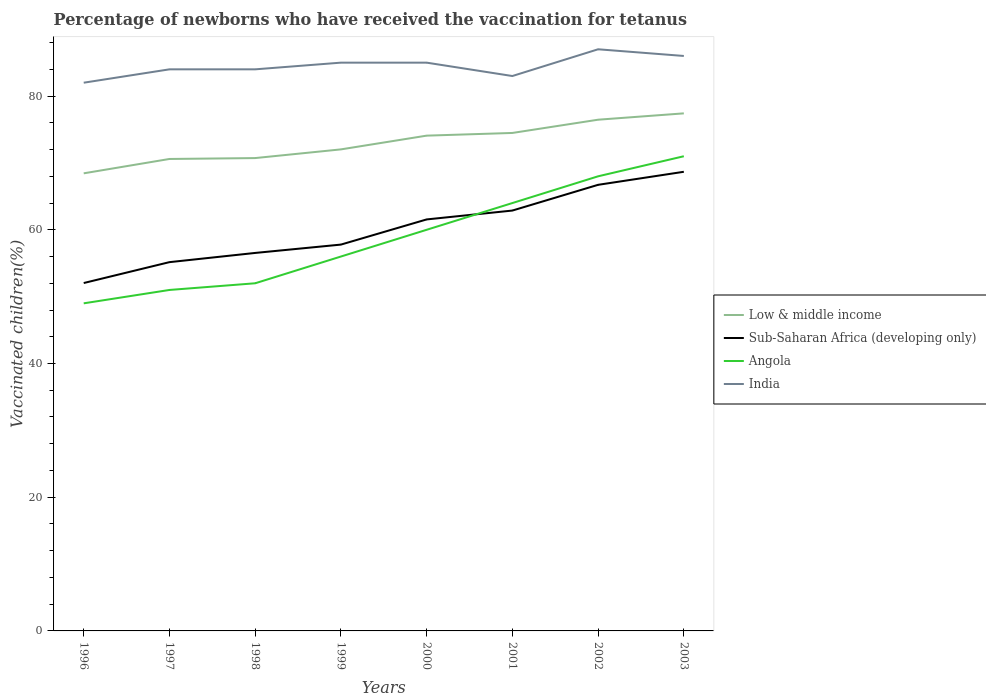How many different coloured lines are there?
Ensure brevity in your answer.  4. Does the line corresponding to Low & middle income intersect with the line corresponding to Sub-Saharan Africa (developing only)?
Offer a very short reply. No. Is the number of lines equal to the number of legend labels?
Keep it short and to the point. Yes. Across all years, what is the maximum percentage of vaccinated children in Low & middle income?
Offer a terse response. 68.45. What is the total percentage of vaccinated children in Sub-Saharan Africa (developing only) in the graph?
Provide a succinct answer. -7.13. What is the difference between the highest and the second highest percentage of vaccinated children in Sub-Saharan Africa (developing only)?
Provide a succinct answer. 16.64. What is the difference between the highest and the lowest percentage of vaccinated children in Sub-Saharan Africa (developing only)?
Your answer should be compact. 4. Is the percentage of vaccinated children in Angola strictly greater than the percentage of vaccinated children in Low & middle income over the years?
Make the answer very short. Yes. How many lines are there?
Offer a very short reply. 4. Does the graph contain any zero values?
Provide a short and direct response. No. How many legend labels are there?
Keep it short and to the point. 4. What is the title of the graph?
Your answer should be compact. Percentage of newborns who have received the vaccination for tetanus. What is the label or title of the X-axis?
Your answer should be very brief. Years. What is the label or title of the Y-axis?
Your answer should be very brief. Vaccinated children(%). What is the Vaccinated children(%) of Low & middle income in 1996?
Make the answer very short. 68.45. What is the Vaccinated children(%) of Sub-Saharan Africa (developing only) in 1996?
Give a very brief answer. 52.04. What is the Vaccinated children(%) of Angola in 1996?
Your answer should be very brief. 49. What is the Vaccinated children(%) in Low & middle income in 1997?
Your response must be concise. 70.59. What is the Vaccinated children(%) of Sub-Saharan Africa (developing only) in 1997?
Provide a short and direct response. 55.16. What is the Vaccinated children(%) of Angola in 1997?
Offer a terse response. 51. What is the Vaccinated children(%) in India in 1997?
Your answer should be very brief. 84. What is the Vaccinated children(%) in Low & middle income in 1998?
Make the answer very short. 70.73. What is the Vaccinated children(%) of Sub-Saharan Africa (developing only) in 1998?
Your answer should be compact. 56.54. What is the Vaccinated children(%) of Low & middle income in 1999?
Provide a short and direct response. 72.03. What is the Vaccinated children(%) of Sub-Saharan Africa (developing only) in 1999?
Your answer should be compact. 57.79. What is the Vaccinated children(%) of Angola in 1999?
Keep it short and to the point. 56. What is the Vaccinated children(%) in Low & middle income in 2000?
Keep it short and to the point. 74.08. What is the Vaccinated children(%) in Sub-Saharan Africa (developing only) in 2000?
Offer a terse response. 61.55. What is the Vaccinated children(%) of India in 2000?
Keep it short and to the point. 85. What is the Vaccinated children(%) of Low & middle income in 2001?
Your response must be concise. 74.48. What is the Vaccinated children(%) in Sub-Saharan Africa (developing only) in 2001?
Your response must be concise. 62.88. What is the Vaccinated children(%) in India in 2001?
Give a very brief answer. 83. What is the Vaccinated children(%) of Low & middle income in 2002?
Your response must be concise. 76.47. What is the Vaccinated children(%) of Sub-Saharan Africa (developing only) in 2002?
Provide a succinct answer. 66.73. What is the Vaccinated children(%) in Angola in 2002?
Keep it short and to the point. 68. What is the Vaccinated children(%) of India in 2002?
Offer a very short reply. 87. What is the Vaccinated children(%) in Low & middle income in 2003?
Your response must be concise. 77.41. What is the Vaccinated children(%) in Sub-Saharan Africa (developing only) in 2003?
Your response must be concise. 68.68. What is the Vaccinated children(%) of India in 2003?
Offer a terse response. 86. Across all years, what is the maximum Vaccinated children(%) in Low & middle income?
Keep it short and to the point. 77.41. Across all years, what is the maximum Vaccinated children(%) of Sub-Saharan Africa (developing only)?
Your response must be concise. 68.68. Across all years, what is the maximum Vaccinated children(%) in Angola?
Make the answer very short. 71. Across all years, what is the minimum Vaccinated children(%) in Low & middle income?
Make the answer very short. 68.45. Across all years, what is the minimum Vaccinated children(%) of Sub-Saharan Africa (developing only)?
Give a very brief answer. 52.04. Across all years, what is the minimum Vaccinated children(%) in India?
Provide a succinct answer. 82. What is the total Vaccinated children(%) of Low & middle income in the graph?
Your answer should be compact. 584.24. What is the total Vaccinated children(%) of Sub-Saharan Africa (developing only) in the graph?
Make the answer very short. 481.35. What is the total Vaccinated children(%) in Angola in the graph?
Keep it short and to the point. 471. What is the total Vaccinated children(%) in India in the graph?
Offer a very short reply. 676. What is the difference between the Vaccinated children(%) of Low & middle income in 1996 and that in 1997?
Ensure brevity in your answer.  -2.15. What is the difference between the Vaccinated children(%) in Sub-Saharan Africa (developing only) in 1996 and that in 1997?
Your answer should be compact. -3.13. What is the difference between the Vaccinated children(%) of Angola in 1996 and that in 1997?
Your response must be concise. -2. What is the difference between the Vaccinated children(%) in India in 1996 and that in 1997?
Provide a short and direct response. -2. What is the difference between the Vaccinated children(%) of Low & middle income in 1996 and that in 1998?
Ensure brevity in your answer.  -2.28. What is the difference between the Vaccinated children(%) of Sub-Saharan Africa (developing only) in 1996 and that in 1998?
Keep it short and to the point. -4.5. What is the difference between the Vaccinated children(%) of Angola in 1996 and that in 1998?
Keep it short and to the point. -3. What is the difference between the Vaccinated children(%) in India in 1996 and that in 1998?
Provide a short and direct response. -2. What is the difference between the Vaccinated children(%) of Low & middle income in 1996 and that in 1999?
Offer a very short reply. -3.58. What is the difference between the Vaccinated children(%) of Sub-Saharan Africa (developing only) in 1996 and that in 1999?
Your response must be concise. -5.75. What is the difference between the Vaccinated children(%) in Angola in 1996 and that in 1999?
Offer a very short reply. -7. What is the difference between the Vaccinated children(%) of India in 1996 and that in 1999?
Your answer should be compact. -3. What is the difference between the Vaccinated children(%) in Low & middle income in 1996 and that in 2000?
Keep it short and to the point. -5.64. What is the difference between the Vaccinated children(%) of Sub-Saharan Africa (developing only) in 1996 and that in 2000?
Your response must be concise. -9.51. What is the difference between the Vaccinated children(%) in Angola in 1996 and that in 2000?
Keep it short and to the point. -11. What is the difference between the Vaccinated children(%) in Low & middle income in 1996 and that in 2001?
Your response must be concise. -6.04. What is the difference between the Vaccinated children(%) of Sub-Saharan Africa (developing only) in 1996 and that in 2001?
Offer a very short reply. -10.84. What is the difference between the Vaccinated children(%) in Angola in 1996 and that in 2001?
Your response must be concise. -15. What is the difference between the Vaccinated children(%) in Low & middle income in 1996 and that in 2002?
Your answer should be very brief. -8.02. What is the difference between the Vaccinated children(%) of Sub-Saharan Africa (developing only) in 1996 and that in 2002?
Provide a short and direct response. -14.69. What is the difference between the Vaccinated children(%) of Low & middle income in 1996 and that in 2003?
Provide a succinct answer. -8.97. What is the difference between the Vaccinated children(%) in Sub-Saharan Africa (developing only) in 1996 and that in 2003?
Provide a succinct answer. -16.64. What is the difference between the Vaccinated children(%) of Angola in 1996 and that in 2003?
Offer a very short reply. -22. What is the difference between the Vaccinated children(%) in India in 1996 and that in 2003?
Your answer should be compact. -4. What is the difference between the Vaccinated children(%) in Low & middle income in 1997 and that in 1998?
Ensure brevity in your answer.  -0.13. What is the difference between the Vaccinated children(%) of Sub-Saharan Africa (developing only) in 1997 and that in 1998?
Provide a succinct answer. -1.38. What is the difference between the Vaccinated children(%) of Angola in 1997 and that in 1998?
Ensure brevity in your answer.  -1. What is the difference between the Vaccinated children(%) of India in 1997 and that in 1998?
Your answer should be very brief. 0. What is the difference between the Vaccinated children(%) in Low & middle income in 1997 and that in 1999?
Your answer should be compact. -1.43. What is the difference between the Vaccinated children(%) in Sub-Saharan Africa (developing only) in 1997 and that in 1999?
Your answer should be compact. -2.62. What is the difference between the Vaccinated children(%) of Low & middle income in 1997 and that in 2000?
Provide a succinct answer. -3.49. What is the difference between the Vaccinated children(%) of Sub-Saharan Africa (developing only) in 1997 and that in 2000?
Offer a terse response. -6.39. What is the difference between the Vaccinated children(%) of Low & middle income in 1997 and that in 2001?
Your answer should be compact. -3.89. What is the difference between the Vaccinated children(%) of Sub-Saharan Africa (developing only) in 1997 and that in 2001?
Keep it short and to the point. -7.72. What is the difference between the Vaccinated children(%) of India in 1997 and that in 2001?
Your response must be concise. 1. What is the difference between the Vaccinated children(%) in Low & middle income in 1997 and that in 2002?
Ensure brevity in your answer.  -5.87. What is the difference between the Vaccinated children(%) of Sub-Saharan Africa (developing only) in 1997 and that in 2002?
Your answer should be very brief. -11.57. What is the difference between the Vaccinated children(%) in Low & middle income in 1997 and that in 2003?
Ensure brevity in your answer.  -6.82. What is the difference between the Vaccinated children(%) in Sub-Saharan Africa (developing only) in 1997 and that in 2003?
Your answer should be very brief. -13.52. What is the difference between the Vaccinated children(%) in Angola in 1997 and that in 2003?
Offer a very short reply. -20. What is the difference between the Vaccinated children(%) of Low & middle income in 1998 and that in 1999?
Your answer should be very brief. -1.3. What is the difference between the Vaccinated children(%) in Sub-Saharan Africa (developing only) in 1998 and that in 1999?
Provide a short and direct response. -1.25. What is the difference between the Vaccinated children(%) in Angola in 1998 and that in 1999?
Keep it short and to the point. -4. What is the difference between the Vaccinated children(%) in Low & middle income in 1998 and that in 2000?
Give a very brief answer. -3.36. What is the difference between the Vaccinated children(%) of Sub-Saharan Africa (developing only) in 1998 and that in 2000?
Make the answer very short. -5.01. What is the difference between the Vaccinated children(%) in Low & middle income in 1998 and that in 2001?
Provide a succinct answer. -3.76. What is the difference between the Vaccinated children(%) in Sub-Saharan Africa (developing only) in 1998 and that in 2001?
Provide a short and direct response. -6.34. What is the difference between the Vaccinated children(%) in Low & middle income in 1998 and that in 2002?
Provide a short and direct response. -5.74. What is the difference between the Vaccinated children(%) of Sub-Saharan Africa (developing only) in 1998 and that in 2002?
Offer a very short reply. -10.19. What is the difference between the Vaccinated children(%) of India in 1998 and that in 2002?
Your answer should be very brief. -3. What is the difference between the Vaccinated children(%) in Low & middle income in 1998 and that in 2003?
Offer a very short reply. -6.69. What is the difference between the Vaccinated children(%) in Sub-Saharan Africa (developing only) in 1998 and that in 2003?
Offer a very short reply. -12.14. What is the difference between the Vaccinated children(%) of Angola in 1998 and that in 2003?
Make the answer very short. -19. What is the difference between the Vaccinated children(%) of India in 1998 and that in 2003?
Your answer should be compact. -2. What is the difference between the Vaccinated children(%) in Low & middle income in 1999 and that in 2000?
Keep it short and to the point. -2.06. What is the difference between the Vaccinated children(%) of Sub-Saharan Africa (developing only) in 1999 and that in 2000?
Your response must be concise. -3.76. What is the difference between the Vaccinated children(%) of Low & middle income in 1999 and that in 2001?
Ensure brevity in your answer.  -2.46. What is the difference between the Vaccinated children(%) of Sub-Saharan Africa (developing only) in 1999 and that in 2001?
Your answer should be very brief. -5.09. What is the difference between the Vaccinated children(%) in Angola in 1999 and that in 2001?
Keep it short and to the point. -8. What is the difference between the Vaccinated children(%) of Low & middle income in 1999 and that in 2002?
Your response must be concise. -4.44. What is the difference between the Vaccinated children(%) in Sub-Saharan Africa (developing only) in 1999 and that in 2002?
Provide a succinct answer. -8.94. What is the difference between the Vaccinated children(%) of Low & middle income in 1999 and that in 2003?
Your answer should be very brief. -5.39. What is the difference between the Vaccinated children(%) of Sub-Saharan Africa (developing only) in 1999 and that in 2003?
Keep it short and to the point. -10.89. What is the difference between the Vaccinated children(%) of India in 1999 and that in 2003?
Your answer should be compact. -1. What is the difference between the Vaccinated children(%) of Low & middle income in 2000 and that in 2001?
Your response must be concise. -0.4. What is the difference between the Vaccinated children(%) in Sub-Saharan Africa (developing only) in 2000 and that in 2001?
Make the answer very short. -1.33. What is the difference between the Vaccinated children(%) in Low & middle income in 2000 and that in 2002?
Provide a succinct answer. -2.38. What is the difference between the Vaccinated children(%) in Sub-Saharan Africa (developing only) in 2000 and that in 2002?
Provide a short and direct response. -5.18. What is the difference between the Vaccinated children(%) of Angola in 2000 and that in 2002?
Your response must be concise. -8. What is the difference between the Vaccinated children(%) in Low & middle income in 2000 and that in 2003?
Keep it short and to the point. -3.33. What is the difference between the Vaccinated children(%) in Sub-Saharan Africa (developing only) in 2000 and that in 2003?
Make the answer very short. -7.13. What is the difference between the Vaccinated children(%) of Low & middle income in 2001 and that in 2002?
Make the answer very short. -1.98. What is the difference between the Vaccinated children(%) of Sub-Saharan Africa (developing only) in 2001 and that in 2002?
Your answer should be compact. -3.85. What is the difference between the Vaccinated children(%) in India in 2001 and that in 2002?
Provide a short and direct response. -4. What is the difference between the Vaccinated children(%) in Low & middle income in 2001 and that in 2003?
Offer a terse response. -2.93. What is the difference between the Vaccinated children(%) of Sub-Saharan Africa (developing only) in 2001 and that in 2003?
Ensure brevity in your answer.  -5.8. What is the difference between the Vaccinated children(%) of Low & middle income in 2002 and that in 2003?
Provide a short and direct response. -0.95. What is the difference between the Vaccinated children(%) of Sub-Saharan Africa (developing only) in 2002 and that in 2003?
Your response must be concise. -1.95. What is the difference between the Vaccinated children(%) in Angola in 2002 and that in 2003?
Provide a short and direct response. -3. What is the difference between the Vaccinated children(%) in Low & middle income in 1996 and the Vaccinated children(%) in Sub-Saharan Africa (developing only) in 1997?
Keep it short and to the point. 13.28. What is the difference between the Vaccinated children(%) of Low & middle income in 1996 and the Vaccinated children(%) of Angola in 1997?
Your answer should be compact. 17.45. What is the difference between the Vaccinated children(%) in Low & middle income in 1996 and the Vaccinated children(%) in India in 1997?
Ensure brevity in your answer.  -15.55. What is the difference between the Vaccinated children(%) of Sub-Saharan Africa (developing only) in 1996 and the Vaccinated children(%) of Angola in 1997?
Give a very brief answer. 1.04. What is the difference between the Vaccinated children(%) of Sub-Saharan Africa (developing only) in 1996 and the Vaccinated children(%) of India in 1997?
Your response must be concise. -31.96. What is the difference between the Vaccinated children(%) in Angola in 1996 and the Vaccinated children(%) in India in 1997?
Make the answer very short. -35. What is the difference between the Vaccinated children(%) of Low & middle income in 1996 and the Vaccinated children(%) of Sub-Saharan Africa (developing only) in 1998?
Your answer should be very brief. 11.91. What is the difference between the Vaccinated children(%) of Low & middle income in 1996 and the Vaccinated children(%) of Angola in 1998?
Keep it short and to the point. 16.45. What is the difference between the Vaccinated children(%) in Low & middle income in 1996 and the Vaccinated children(%) in India in 1998?
Provide a succinct answer. -15.55. What is the difference between the Vaccinated children(%) of Sub-Saharan Africa (developing only) in 1996 and the Vaccinated children(%) of Angola in 1998?
Your answer should be very brief. 0.04. What is the difference between the Vaccinated children(%) in Sub-Saharan Africa (developing only) in 1996 and the Vaccinated children(%) in India in 1998?
Ensure brevity in your answer.  -31.96. What is the difference between the Vaccinated children(%) of Angola in 1996 and the Vaccinated children(%) of India in 1998?
Your answer should be compact. -35. What is the difference between the Vaccinated children(%) in Low & middle income in 1996 and the Vaccinated children(%) in Sub-Saharan Africa (developing only) in 1999?
Provide a short and direct response. 10.66. What is the difference between the Vaccinated children(%) in Low & middle income in 1996 and the Vaccinated children(%) in Angola in 1999?
Your answer should be compact. 12.45. What is the difference between the Vaccinated children(%) in Low & middle income in 1996 and the Vaccinated children(%) in India in 1999?
Give a very brief answer. -16.55. What is the difference between the Vaccinated children(%) in Sub-Saharan Africa (developing only) in 1996 and the Vaccinated children(%) in Angola in 1999?
Your answer should be very brief. -3.96. What is the difference between the Vaccinated children(%) in Sub-Saharan Africa (developing only) in 1996 and the Vaccinated children(%) in India in 1999?
Your answer should be very brief. -32.96. What is the difference between the Vaccinated children(%) of Angola in 1996 and the Vaccinated children(%) of India in 1999?
Offer a very short reply. -36. What is the difference between the Vaccinated children(%) in Low & middle income in 1996 and the Vaccinated children(%) in Sub-Saharan Africa (developing only) in 2000?
Your response must be concise. 6.9. What is the difference between the Vaccinated children(%) of Low & middle income in 1996 and the Vaccinated children(%) of Angola in 2000?
Keep it short and to the point. 8.45. What is the difference between the Vaccinated children(%) of Low & middle income in 1996 and the Vaccinated children(%) of India in 2000?
Make the answer very short. -16.55. What is the difference between the Vaccinated children(%) of Sub-Saharan Africa (developing only) in 1996 and the Vaccinated children(%) of Angola in 2000?
Your answer should be very brief. -7.96. What is the difference between the Vaccinated children(%) in Sub-Saharan Africa (developing only) in 1996 and the Vaccinated children(%) in India in 2000?
Your answer should be compact. -32.96. What is the difference between the Vaccinated children(%) of Angola in 1996 and the Vaccinated children(%) of India in 2000?
Offer a very short reply. -36. What is the difference between the Vaccinated children(%) in Low & middle income in 1996 and the Vaccinated children(%) in Sub-Saharan Africa (developing only) in 2001?
Provide a succinct answer. 5.57. What is the difference between the Vaccinated children(%) of Low & middle income in 1996 and the Vaccinated children(%) of Angola in 2001?
Your response must be concise. 4.45. What is the difference between the Vaccinated children(%) of Low & middle income in 1996 and the Vaccinated children(%) of India in 2001?
Give a very brief answer. -14.55. What is the difference between the Vaccinated children(%) of Sub-Saharan Africa (developing only) in 1996 and the Vaccinated children(%) of Angola in 2001?
Your answer should be compact. -11.96. What is the difference between the Vaccinated children(%) of Sub-Saharan Africa (developing only) in 1996 and the Vaccinated children(%) of India in 2001?
Provide a short and direct response. -30.96. What is the difference between the Vaccinated children(%) of Angola in 1996 and the Vaccinated children(%) of India in 2001?
Keep it short and to the point. -34. What is the difference between the Vaccinated children(%) in Low & middle income in 1996 and the Vaccinated children(%) in Sub-Saharan Africa (developing only) in 2002?
Give a very brief answer. 1.72. What is the difference between the Vaccinated children(%) in Low & middle income in 1996 and the Vaccinated children(%) in Angola in 2002?
Offer a very short reply. 0.45. What is the difference between the Vaccinated children(%) in Low & middle income in 1996 and the Vaccinated children(%) in India in 2002?
Your response must be concise. -18.55. What is the difference between the Vaccinated children(%) in Sub-Saharan Africa (developing only) in 1996 and the Vaccinated children(%) in Angola in 2002?
Give a very brief answer. -15.96. What is the difference between the Vaccinated children(%) in Sub-Saharan Africa (developing only) in 1996 and the Vaccinated children(%) in India in 2002?
Keep it short and to the point. -34.96. What is the difference between the Vaccinated children(%) of Angola in 1996 and the Vaccinated children(%) of India in 2002?
Your answer should be very brief. -38. What is the difference between the Vaccinated children(%) in Low & middle income in 1996 and the Vaccinated children(%) in Sub-Saharan Africa (developing only) in 2003?
Your response must be concise. -0.23. What is the difference between the Vaccinated children(%) of Low & middle income in 1996 and the Vaccinated children(%) of Angola in 2003?
Give a very brief answer. -2.55. What is the difference between the Vaccinated children(%) of Low & middle income in 1996 and the Vaccinated children(%) of India in 2003?
Provide a short and direct response. -17.55. What is the difference between the Vaccinated children(%) of Sub-Saharan Africa (developing only) in 1996 and the Vaccinated children(%) of Angola in 2003?
Make the answer very short. -18.96. What is the difference between the Vaccinated children(%) in Sub-Saharan Africa (developing only) in 1996 and the Vaccinated children(%) in India in 2003?
Offer a terse response. -33.96. What is the difference between the Vaccinated children(%) in Angola in 1996 and the Vaccinated children(%) in India in 2003?
Make the answer very short. -37. What is the difference between the Vaccinated children(%) in Low & middle income in 1997 and the Vaccinated children(%) in Sub-Saharan Africa (developing only) in 1998?
Make the answer very short. 14.06. What is the difference between the Vaccinated children(%) of Low & middle income in 1997 and the Vaccinated children(%) of Angola in 1998?
Provide a short and direct response. 18.59. What is the difference between the Vaccinated children(%) of Low & middle income in 1997 and the Vaccinated children(%) of India in 1998?
Offer a very short reply. -13.41. What is the difference between the Vaccinated children(%) in Sub-Saharan Africa (developing only) in 1997 and the Vaccinated children(%) in Angola in 1998?
Your answer should be compact. 3.16. What is the difference between the Vaccinated children(%) of Sub-Saharan Africa (developing only) in 1997 and the Vaccinated children(%) of India in 1998?
Your answer should be very brief. -28.84. What is the difference between the Vaccinated children(%) in Angola in 1997 and the Vaccinated children(%) in India in 1998?
Give a very brief answer. -33. What is the difference between the Vaccinated children(%) of Low & middle income in 1997 and the Vaccinated children(%) of Sub-Saharan Africa (developing only) in 1999?
Offer a very short reply. 12.81. What is the difference between the Vaccinated children(%) in Low & middle income in 1997 and the Vaccinated children(%) in Angola in 1999?
Offer a terse response. 14.59. What is the difference between the Vaccinated children(%) of Low & middle income in 1997 and the Vaccinated children(%) of India in 1999?
Offer a very short reply. -14.41. What is the difference between the Vaccinated children(%) in Sub-Saharan Africa (developing only) in 1997 and the Vaccinated children(%) in Angola in 1999?
Make the answer very short. -0.84. What is the difference between the Vaccinated children(%) in Sub-Saharan Africa (developing only) in 1997 and the Vaccinated children(%) in India in 1999?
Give a very brief answer. -29.84. What is the difference between the Vaccinated children(%) of Angola in 1997 and the Vaccinated children(%) of India in 1999?
Offer a terse response. -34. What is the difference between the Vaccinated children(%) of Low & middle income in 1997 and the Vaccinated children(%) of Sub-Saharan Africa (developing only) in 2000?
Provide a short and direct response. 9.04. What is the difference between the Vaccinated children(%) of Low & middle income in 1997 and the Vaccinated children(%) of Angola in 2000?
Your answer should be very brief. 10.59. What is the difference between the Vaccinated children(%) of Low & middle income in 1997 and the Vaccinated children(%) of India in 2000?
Offer a terse response. -14.41. What is the difference between the Vaccinated children(%) of Sub-Saharan Africa (developing only) in 1997 and the Vaccinated children(%) of Angola in 2000?
Your answer should be very brief. -4.84. What is the difference between the Vaccinated children(%) of Sub-Saharan Africa (developing only) in 1997 and the Vaccinated children(%) of India in 2000?
Offer a very short reply. -29.84. What is the difference between the Vaccinated children(%) in Angola in 1997 and the Vaccinated children(%) in India in 2000?
Your answer should be very brief. -34. What is the difference between the Vaccinated children(%) in Low & middle income in 1997 and the Vaccinated children(%) in Sub-Saharan Africa (developing only) in 2001?
Provide a succinct answer. 7.72. What is the difference between the Vaccinated children(%) of Low & middle income in 1997 and the Vaccinated children(%) of Angola in 2001?
Offer a very short reply. 6.59. What is the difference between the Vaccinated children(%) of Low & middle income in 1997 and the Vaccinated children(%) of India in 2001?
Make the answer very short. -12.41. What is the difference between the Vaccinated children(%) in Sub-Saharan Africa (developing only) in 1997 and the Vaccinated children(%) in Angola in 2001?
Provide a short and direct response. -8.84. What is the difference between the Vaccinated children(%) of Sub-Saharan Africa (developing only) in 1997 and the Vaccinated children(%) of India in 2001?
Keep it short and to the point. -27.84. What is the difference between the Vaccinated children(%) of Angola in 1997 and the Vaccinated children(%) of India in 2001?
Make the answer very short. -32. What is the difference between the Vaccinated children(%) of Low & middle income in 1997 and the Vaccinated children(%) of Sub-Saharan Africa (developing only) in 2002?
Your answer should be very brief. 3.87. What is the difference between the Vaccinated children(%) in Low & middle income in 1997 and the Vaccinated children(%) in Angola in 2002?
Give a very brief answer. 2.59. What is the difference between the Vaccinated children(%) of Low & middle income in 1997 and the Vaccinated children(%) of India in 2002?
Offer a very short reply. -16.41. What is the difference between the Vaccinated children(%) of Sub-Saharan Africa (developing only) in 1997 and the Vaccinated children(%) of Angola in 2002?
Offer a terse response. -12.84. What is the difference between the Vaccinated children(%) in Sub-Saharan Africa (developing only) in 1997 and the Vaccinated children(%) in India in 2002?
Offer a terse response. -31.84. What is the difference between the Vaccinated children(%) in Angola in 1997 and the Vaccinated children(%) in India in 2002?
Offer a very short reply. -36. What is the difference between the Vaccinated children(%) of Low & middle income in 1997 and the Vaccinated children(%) of Sub-Saharan Africa (developing only) in 2003?
Offer a terse response. 1.92. What is the difference between the Vaccinated children(%) of Low & middle income in 1997 and the Vaccinated children(%) of Angola in 2003?
Give a very brief answer. -0.41. What is the difference between the Vaccinated children(%) in Low & middle income in 1997 and the Vaccinated children(%) in India in 2003?
Give a very brief answer. -15.41. What is the difference between the Vaccinated children(%) of Sub-Saharan Africa (developing only) in 1997 and the Vaccinated children(%) of Angola in 2003?
Provide a succinct answer. -15.84. What is the difference between the Vaccinated children(%) of Sub-Saharan Africa (developing only) in 1997 and the Vaccinated children(%) of India in 2003?
Your answer should be compact. -30.84. What is the difference between the Vaccinated children(%) in Angola in 1997 and the Vaccinated children(%) in India in 2003?
Your answer should be compact. -35. What is the difference between the Vaccinated children(%) in Low & middle income in 1998 and the Vaccinated children(%) in Sub-Saharan Africa (developing only) in 1999?
Your answer should be very brief. 12.94. What is the difference between the Vaccinated children(%) in Low & middle income in 1998 and the Vaccinated children(%) in Angola in 1999?
Your answer should be compact. 14.73. What is the difference between the Vaccinated children(%) of Low & middle income in 1998 and the Vaccinated children(%) of India in 1999?
Your answer should be compact. -14.27. What is the difference between the Vaccinated children(%) in Sub-Saharan Africa (developing only) in 1998 and the Vaccinated children(%) in Angola in 1999?
Offer a very short reply. 0.54. What is the difference between the Vaccinated children(%) of Sub-Saharan Africa (developing only) in 1998 and the Vaccinated children(%) of India in 1999?
Provide a succinct answer. -28.46. What is the difference between the Vaccinated children(%) in Angola in 1998 and the Vaccinated children(%) in India in 1999?
Offer a very short reply. -33. What is the difference between the Vaccinated children(%) in Low & middle income in 1998 and the Vaccinated children(%) in Sub-Saharan Africa (developing only) in 2000?
Your response must be concise. 9.18. What is the difference between the Vaccinated children(%) of Low & middle income in 1998 and the Vaccinated children(%) of Angola in 2000?
Your answer should be very brief. 10.73. What is the difference between the Vaccinated children(%) of Low & middle income in 1998 and the Vaccinated children(%) of India in 2000?
Offer a very short reply. -14.27. What is the difference between the Vaccinated children(%) in Sub-Saharan Africa (developing only) in 1998 and the Vaccinated children(%) in Angola in 2000?
Offer a terse response. -3.46. What is the difference between the Vaccinated children(%) of Sub-Saharan Africa (developing only) in 1998 and the Vaccinated children(%) of India in 2000?
Offer a very short reply. -28.46. What is the difference between the Vaccinated children(%) in Angola in 1998 and the Vaccinated children(%) in India in 2000?
Your answer should be compact. -33. What is the difference between the Vaccinated children(%) of Low & middle income in 1998 and the Vaccinated children(%) of Sub-Saharan Africa (developing only) in 2001?
Make the answer very short. 7.85. What is the difference between the Vaccinated children(%) of Low & middle income in 1998 and the Vaccinated children(%) of Angola in 2001?
Your answer should be very brief. 6.73. What is the difference between the Vaccinated children(%) of Low & middle income in 1998 and the Vaccinated children(%) of India in 2001?
Give a very brief answer. -12.27. What is the difference between the Vaccinated children(%) of Sub-Saharan Africa (developing only) in 1998 and the Vaccinated children(%) of Angola in 2001?
Provide a short and direct response. -7.46. What is the difference between the Vaccinated children(%) in Sub-Saharan Africa (developing only) in 1998 and the Vaccinated children(%) in India in 2001?
Give a very brief answer. -26.46. What is the difference between the Vaccinated children(%) in Angola in 1998 and the Vaccinated children(%) in India in 2001?
Keep it short and to the point. -31. What is the difference between the Vaccinated children(%) in Low & middle income in 1998 and the Vaccinated children(%) in Sub-Saharan Africa (developing only) in 2002?
Your response must be concise. 4. What is the difference between the Vaccinated children(%) of Low & middle income in 1998 and the Vaccinated children(%) of Angola in 2002?
Provide a succinct answer. 2.73. What is the difference between the Vaccinated children(%) in Low & middle income in 1998 and the Vaccinated children(%) in India in 2002?
Your answer should be compact. -16.27. What is the difference between the Vaccinated children(%) in Sub-Saharan Africa (developing only) in 1998 and the Vaccinated children(%) in Angola in 2002?
Offer a very short reply. -11.46. What is the difference between the Vaccinated children(%) of Sub-Saharan Africa (developing only) in 1998 and the Vaccinated children(%) of India in 2002?
Your response must be concise. -30.46. What is the difference between the Vaccinated children(%) of Angola in 1998 and the Vaccinated children(%) of India in 2002?
Ensure brevity in your answer.  -35. What is the difference between the Vaccinated children(%) of Low & middle income in 1998 and the Vaccinated children(%) of Sub-Saharan Africa (developing only) in 2003?
Ensure brevity in your answer.  2.05. What is the difference between the Vaccinated children(%) of Low & middle income in 1998 and the Vaccinated children(%) of Angola in 2003?
Keep it short and to the point. -0.27. What is the difference between the Vaccinated children(%) of Low & middle income in 1998 and the Vaccinated children(%) of India in 2003?
Ensure brevity in your answer.  -15.27. What is the difference between the Vaccinated children(%) of Sub-Saharan Africa (developing only) in 1998 and the Vaccinated children(%) of Angola in 2003?
Make the answer very short. -14.46. What is the difference between the Vaccinated children(%) of Sub-Saharan Africa (developing only) in 1998 and the Vaccinated children(%) of India in 2003?
Your answer should be very brief. -29.46. What is the difference between the Vaccinated children(%) in Angola in 1998 and the Vaccinated children(%) in India in 2003?
Ensure brevity in your answer.  -34. What is the difference between the Vaccinated children(%) in Low & middle income in 1999 and the Vaccinated children(%) in Sub-Saharan Africa (developing only) in 2000?
Your answer should be very brief. 10.48. What is the difference between the Vaccinated children(%) of Low & middle income in 1999 and the Vaccinated children(%) of Angola in 2000?
Offer a terse response. 12.03. What is the difference between the Vaccinated children(%) in Low & middle income in 1999 and the Vaccinated children(%) in India in 2000?
Provide a short and direct response. -12.97. What is the difference between the Vaccinated children(%) in Sub-Saharan Africa (developing only) in 1999 and the Vaccinated children(%) in Angola in 2000?
Make the answer very short. -2.21. What is the difference between the Vaccinated children(%) of Sub-Saharan Africa (developing only) in 1999 and the Vaccinated children(%) of India in 2000?
Offer a very short reply. -27.21. What is the difference between the Vaccinated children(%) of Angola in 1999 and the Vaccinated children(%) of India in 2000?
Offer a very short reply. -29. What is the difference between the Vaccinated children(%) of Low & middle income in 1999 and the Vaccinated children(%) of Sub-Saharan Africa (developing only) in 2001?
Your answer should be very brief. 9.15. What is the difference between the Vaccinated children(%) of Low & middle income in 1999 and the Vaccinated children(%) of Angola in 2001?
Your answer should be compact. 8.03. What is the difference between the Vaccinated children(%) in Low & middle income in 1999 and the Vaccinated children(%) in India in 2001?
Your answer should be compact. -10.97. What is the difference between the Vaccinated children(%) of Sub-Saharan Africa (developing only) in 1999 and the Vaccinated children(%) of Angola in 2001?
Offer a terse response. -6.21. What is the difference between the Vaccinated children(%) of Sub-Saharan Africa (developing only) in 1999 and the Vaccinated children(%) of India in 2001?
Give a very brief answer. -25.21. What is the difference between the Vaccinated children(%) of Angola in 1999 and the Vaccinated children(%) of India in 2001?
Give a very brief answer. -27. What is the difference between the Vaccinated children(%) of Low & middle income in 1999 and the Vaccinated children(%) of Sub-Saharan Africa (developing only) in 2002?
Keep it short and to the point. 5.3. What is the difference between the Vaccinated children(%) in Low & middle income in 1999 and the Vaccinated children(%) in Angola in 2002?
Your answer should be very brief. 4.03. What is the difference between the Vaccinated children(%) in Low & middle income in 1999 and the Vaccinated children(%) in India in 2002?
Offer a terse response. -14.97. What is the difference between the Vaccinated children(%) in Sub-Saharan Africa (developing only) in 1999 and the Vaccinated children(%) in Angola in 2002?
Offer a very short reply. -10.21. What is the difference between the Vaccinated children(%) of Sub-Saharan Africa (developing only) in 1999 and the Vaccinated children(%) of India in 2002?
Give a very brief answer. -29.21. What is the difference between the Vaccinated children(%) of Angola in 1999 and the Vaccinated children(%) of India in 2002?
Offer a terse response. -31. What is the difference between the Vaccinated children(%) of Low & middle income in 1999 and the Vaccinated children(%) of Sub-Saharan Africa (developing only) in 2003?
Your response must be concise. 3.35. What is the difference between the Vaccinated children(%) in Low & middle income in 1999 and the Vaccinated children(%) in Angola in 2003?
Offer a terse response. 1.03. What is the difference between the Vaccinated children(%) in Low & middle income in 1999 and the Vaccinated children(%) in India in 2003?
Give a very brief answer. -13.97. What is the difference between the Vaccinated children(%) of Sub-Saharan Africa (developing only) in 1999 and the Vaccinated children(%) of Angola in 2003?
Make the answer very short. -13.21. What is the difference between the Vaccinated children(%) in Sub-Saharan Africa (developing only) in 1999 and the Vaccinated children(%) in India in 2003?
Ensure brevity in your answer.  -28.21. What is the difference between the Vaccinated children(%) of Angola in 1999 and the Vaccinated children(%) of India in 2003?
Offer a very short reply. -30. What is the difference between the Vaccinated children(%) of Low & middle income in 2000 and the Vaccinated children(%) of Sub-Saharan Africa (developing only) in 2001?
Keep it short and to the point. 11.21. What is the difference between the Vaccinated children(%) of Low & middle income in 2000 and the Vaccinated children(%) of Angola in 2001?
Keep it short and to the point. 10.08. What is the difference between the Vaccinated children(%) in Low & middle income in 2000 and the Vaccinated children(%) in India in 2001?
Keep it short and to the point. -8.92. What is the difference between the Vaccinated children(%) in Sub-Saharan Africa (developing only) in 2000 and the Vaccinated children(%) in Angola in 2001?
Your answer should be compact. -2.45. What is the difference between the Vaccinated children(%) in Sub-Saharan Africa (developing only) in 2000 and the Vaccinated children(%) in India in 2001?
Your answer should be compact. -21.45. What is the difference between the Vaccinated children(%) of Low & middle income in 2000 and the Vaccinated children(%) of Sub-Saharan Africa (developing only) in 2002?
Provide a short and direct response. 7.36. What is the difference between the Vaccinated children(%) in Low & middle income in 2000 and the Vaccinated children(%) in Angola in 2002?
Offer a very short reply. 6.08. What is the difference between the Vaccinated children(%) of Low & middle income in 2000 and the Vaccinated children(%) of India in 2002?
Ensure brevity in your answer.  -12.92. What is the difference between the Vaccinated children(%) of Sub-Saharan Africa (developing only) in 2000 and the Vaccinated children(%) of Angola in 2002?
Provide a short and direct response. -6.45. What is the difference between the Vaccinated children(%) in Sub-Saharan Africa (developing only) in 2000 and the Vaccinated children(%) in India in 2002?
Provide a short and direct response. -25.45. What is the difference between the Vaccinated children(%) in Angola in 2000 and the Vaccinated children(%) in India in 2002?
Give a very brief answer. -27. What is the difference between the Vaccinated children(%) of Low & middle income in 2000 and the Vaccinated children(%) of Sub-Saharan Africa (developing only) in 2003?
Offer a terse response. 5.41. What is the difference between the Vaccinated children(%) of Low & middle income in 2000 and the Vaccinated children(%) of Angola in 2003?
Your answer should be very brief. 3.08. What is the difference between the Vaccinated children(%) of Low & middle income in 2000 and the Vaccinated children(%) of India in 2003?
Provide a succinct answer. -11.92. What is the difference between the Vaccinated children(%) of Sub-Saharan Africa (developing only) in 2000 and the Vaccinated children(%) of Angola in 2003?
Offer a terse response. -9.45. What is the difference between the Vaccinated children(%) of Sub-Saharan Africa (developing only) in 2000 and the Vaccinated children(%) of India in 2003?
Make the answer very short. -24.45. What is the difference between the Vaccinated children(%) of Angola in 2000 and the Vaccinated children(%) of India in 2003?
Provide a succinct answer. -26. What is the difference between the Vaccinated children(%) in Low & middle income in 2001 and the Vaccinated children(%) in Sub-Saharan Africa (developing only) in 2002?
Give a very brief answer. 7.76. What is the difference between the Vaccinated children(%) of Low & middle income in 2001 and the Vaccinated children(%) of Angola in 2002?
Your answer should be compact. 6.48. What is the difference between the Vaccinated children(%) in Low & middle income in 2001 and the Vaccinated children(%) in India in 2002?
Provide a short and direct response. -12.52. What is the difference between the Vaccinated children(%) in Sub-Saharan Africa (developing only) in 2001 and the Vaccinated children(%) in Angola in 2002?
Offer a very short reply. -5.12. What is the difference between the Vaccinated children(%) of Sub-Saharan Africa (developing only) in 2001 and the Vaccinated children(%) of India in 2002?
Provide a short and direct response. -24.12. What is the difference between the Vaccinated children(%) of Angola in 2001 and the Vaccinated children(%) of India in 2002?
Give a very brief answer. -23. What is the difference between the Vaccinated children(%) of Low & middle income in 2001 and the Vaccinated children(%) of Sub-Saharan Africa (developing only) in 2003?
Give a very brief answer. 5.81. What is the difference between the Vaccinated children(%) in Low & middle income in 2001 and the Vaccinated children(%) in Angola in 2003?
Make the answer very short. 3.48. What is the difference between the Vaccinated children(%) in Low & middle income in 2001 and the Vaccinated children(%) in India in 2003?
Provide a short and direct response. -11.52. What is the difference between the Vaccinated children(%) of Sub-Saharan Africa (developing only) in 2001 and the Vaccinated children(%) of Angola in 2003?
Give a very brief answer. -8.12. What is the difference between the Vaccinated children(%) in Sub-Saharan Africa (developing only) in 2001 and the Vaccinated children(%) in India in 2003?
Your answer should be compact. -23.12. What is the difference between the Vaccinated children(%) of Low & middle income in 2002 and the Vaccinated children(%) of Sub-Saharan Africa (developing only) in 2003?
Offer a terse response. 7.79. What is the difference between the Vaccinated children(%) of Low & middle income in 2002 and the Vaccinated children(%) of Angola in 2003?
Provide a succinct answer. 5.47. What is the difference between the Vaccinated children(%) in Low & middle income in 2002 and the Vaccinated children(%) in India in 2003?
Ensure brevity in your answer.  -9.53. What is the difference between the Vaccinated children(%) in Sub-Saharan Africa (developing only) in 2002 and the Vaccinated children(%) in Angola in 2003?
Your response must be concise. -4.27. What is the difference between the Vaccinated children(%) of Sub-Saharan Africa (developing only) in 2002 and the Vaccinated children(%) of India in 2003?
Offer a very short reply. -19.27. What is the average Vaccinated children(%) of Low & middle income per year?
Offer a very short reply. 73.03. What is the average Vaccinated children(%) in Sub-Saharan Africa (developing only) per year?
Your response must be concise. 60.17. What is the average Vaccinated children(%) of Angola per year?
Offer a terse response. 58.88. What is the average Vaccinated children(%) of India per year?
Provide a short and direct response. 84.5. In the year 1996, what is the difference between the Vaccinated children(%) of Low & middle income and Vaccinated children(%) of Sub-Saharan Africa (developing only)?
Provide a short and direct response. 16.41. In the year 1996, what is the difference between the Vaccinated children(%) in Low & middle income and Vaccinated children(%) in Angola?
Keep it short and to the point. 19.45. In the year 1996, what is the difference between the Vaccinated children(%) of Low & middle income and Vaccinated children(%) of India?
Your response must be concise. -13.55. In the year 1996, what is the difference between the Vaccinated children(%) in Sub-Saharan Africa (developing only) and Vaccinated children(%) in Angola?
Offer a very short reply. 3.04. In the year 1996, what is the difference between the Vaccinated children(%) in Sub-Saharan Africa (developing only) and Vaccinated children(%) in India?
Keep it short and to the point. -29.96. In the year 1996, what is the difference between the Vaccinated children(%) in Angola and Vaccinated children(%) in India?
Provide a succinct answer. -33. In the year 1997, what is the difference between the Vaccinated children(%) in Low & middle income and Vaccinated children(%) in Sub-Saharan Africa (developing only)?
Provide a succinct answer. 15.43. In the year 1997, what is the difference between the Vaccinated children(%) in Low & middle income and Vaccinated children(%) in Angola?
Provide a short and direct response. 19.59. In the year 1997, what is the difference between the Vaccinated children(%) in Low & middle income and Vaccinated children(%) in India?
Give a very brief answer. -13.41. In the year 1997, what is the difference between the Vaccinated children(%) in Sub-Saharan Africa (developing only) and Vaccinated children(%) in Angola?
Keep it short and to the point. 4.16. In the year 1997, what is the difference between the Vaccinated children(%) in Sub-Saharan Africa (developing only) and Vaccinated children(%) in India?
Provide a succinct answer. -28.84. In the year 1997, what is the difference between the Vaccinated children(%) of Angola and Vaccinated children(%) of India?
Give a very brief answer. -33. In the year 1998, what is the difference between the Vaccinated children(%) of Low & middle income and Vaccinated children(%) of Sub-Saharan Africa (developing only)?
Provide a short and direct response. 14.19. In the year 1998, what is the difference between the Vaccinated children(%) of Low & middle income and Vaccinated children(%) of Angola?
Provide a succinct answer. 18.73. In the year 1998, what is the difference between the Vaccinated children(%) in Low & middle income and Vaccinated children(%) in India?
Keep it short and to the point. -13.27. In the year 1998, what is the difference between the Vaccinated children(%) of Sub-Saharan Africa (developing only) and Vaccinated children(%) of Angola?
Ensure brevity in your answer.  4.54. In the year 1998, what is the difference between the Vaccinated children(%) in Sub-Saharan Africa (developing only) and Vaccinated children(%) in India?
Your response must be concise. -27.46. In the year 1998, what is the difference between the Vaccinated children(%) of Angola and Vaccinated children(%) of India?
Give a very brief answer. -32. In the year 1999, what is the difference between the Vaccinated children(%) of Low & middle income and Vaccinated children(%) of Sub-Saharan Africa (developing only)?
Keep it short and to the point. 14.24. In the year 1999, what is the difference between the Vaccinated children(%) of Low & middle income and Vaccinated children(%) of Angola?
Make the answer very short. 16.03. In the year 1999, what is the difference between the Vaccinated children(%) of Low & middle income and Vaccinated children(%) of India?
Give a very brief answer. -12.97. In the year 1999, what is the difference between the Vaccinated children(%) of Sub-Saharan Africa (developing only) and Vaccinated children(%) of Angola?
Make the answer very short. 1.79. In the year 1999, what is the difference between the Vaccinated children(%) in Sub-Saharan Africa (developing only) and Vaccinated children(%) in India?
Keep it short and to the point. -27.21. In the year 1999, what is the difference between the Vaccinated children(%) of Angola and Vaccinated children(%) of India?
Your answer should be very brief. -29. In the year 2000, what is the difference between the Vaccinated children(%) in Low & middle income and Vaccinated children(%) in Sub-Saharan Africa (developing only)?
Offer a terse response. 12.53. In the year 2000, what is the difference between the Vaccinated children(%) in Low & middle income and Vaccinated children(%) in Angola?
Offer a very short reply. 14.08. In the year 2000, what is the difference between the Vaccinated children(%) of Low & middle income and Vaccinated children(%) of India?
Offer a terse response. -10.92. In the year 2000, what is the difference between the Vaccinated children(%) of Sub-Saharan Africa (developing only) and Vaccinated children(%) of Angola?
Provide a succinct answer. 1.55. In the year 2000, what is the difference between the Vaccinated children(%) in Sub-Saharan Africa (developing only) and Vaccinated children(%) in India?
Provide a short and direct response. -23.45. In the year 2000, what is the difference between the Vaccinated children(%) of Angola and Vaccinated children(%) of India?
Provide a succinct answer. -25. In the year 2001, what is the difference between the Vaccinated children(%) of Low & middle income and Vaccinated children(%) of Sub-Saharan Africa (developing only)?
Make the answer very short. 11.61. In the year 2001, what is the difference between the Vaccinated children(%) of Low & middle income and Vaccinated children(%) of Angola?
Keep it short and to the point. 10.48. In the year 2001, what is the difference between the Vaccinated children(%) in Low & middle income and Vaccinated children(%) in India?
Provide a succinct answer. -8.52. In the year 2001, what is the difference between the Vaccinated children(%) of Sub-Saharan Africa (developing only) and Vaccinated children(%) of Angola?
Offer a terse response. -1.12. In the year 2001, what is the difference between the Vaccinated children(%) of Sub-Saharan Africa (developing only) and Vaccinated children(%) of India?
Offer a very short reply. -20.12. In the year 2002, what is the difference between the Vaccinated children(%) of Low & middle income and Vaccinated children(%) of Sub-Saharan Africa (developing only)?
Your answer should be compact. 9.74. In the year 2002, what is the difference between the Vaccinated children(%) of Low & middle income and Vaccinated children(%) of Angola?
Your answer should be compact. 8.47. In the year 2002, what is the difference between the Vaccinated children(%) in Low & middle income and Vaccinated children(%) in India?
Make the answer very short. -10.53. In the year 2002, what is the difference between the Vaccinated children(%) of Sub-Saharan Africa (developing only) and Vaccinated children(%) of Angola?
Your answer should be compact. -1.27. In the year 2002, what is the difference between the Vaccinated children(%) of Sub-Saharan Africa (developing only) and Vaccinated children(%) of India?
Offer a very short reply. -20.27. In the year 2003, what is the difference between the Vaccinated children(%) in Low & middle income and Vaccinated children(%) in Sub-Saharan Africa (developing only)?
Your answer should be very brief. 8.74. In the year 2003, what is the difference between the Vaccinated children(%) in Low & middle income and Vaccinated children(%) in Angola?
Provide a short and direct response. 6.41. In the year 2003, what is the difference between the Vaccinated children(%) in Low & middle income and Vaccinated children(%) in India?
Your answer should be very brief. -8.59. In the year 2003, what is the difference between the Vaccinated children(%) of Sub-Saharan Africa (developing only) and Vaccinated children(%) of Angola?
Offer a very short reply. -2.32. In the year 2003, what is the difference between the Vaccinated children(%) in Sub-Saharan Africa (developing only) and Vaccinated children(%) in India?
Give a very brief answer. -17.32. In the year 2003, what is the difference between the Vaccinated children(%) in Angola and Vaccinated children(%) in India?
Provide a succinct answer. -15. What is the ratio of the Vaccinated children(%) of Low & middle income in 1996 to that in 1997?
Give a very brief answer. 0.97. What is the ratio of the Vaccinated children(%) in Sub-Saharan Africa (developing only) in 1996 to that in 1997?
Ensure brevity in your answer.  0.94. What is the ratio of the Vaccinated children(%) of Angola in 1996 to that in 1997?
Give a very brief answer. 0.96. What is the ratio of the Vaccinated children(%) in India in 1996 to that in 1997?
Offer a terse response. 0.98. What is the ratio of the Vaccinated children(%) of Low & middle income in 1996 to that in 1998?
Your answer should be very brief. 0.97. What is the ratio of the Vaccinated children(%) of Sub-Saharan Africa (developing only) in 1996 to that in 1998?
Provide a succinct answer. 0.92. What is the ratio of the Vaccinated children(%) of Angola in 1996 to that in 1998?
Your response must be concise. 0.94. What is the ratio of the Vaccinated children(%) in India in 1996 to that in 1998?
Keep it short and to the point. 0.98. What is the ratio of the Vaccinated children(%) in Low & middle income in 1996 to that in 1999?
Ensure brevity in your answer.  0.95. What is the ratio of the Vaccinated children(%) of Sub-Saharan Africa (developing only) in 1996 to that in 1999?
Give a very brief answer. 0.9. What is the ratio of the Vaccinated children(%) in Angola in 1996 to that in 1999?
Make the answer very short. 0.88. What is the ratio of the Vaccinated children(%) of India in 1996 to that in 1999?
Ensure brevity in your answer.  0.96. What is the ratio of the Vaccinated children(%) of Low & middle income in 1996 to that in 2000?
Offer a terse response. 0.92. What is the ratio of the Vaccinated children(%) in Sub-Saharan Africa (developing only) in 1996 to that in 2000?
Your answer should be compact. 0.85. What is the ratio of the Vaccinated children(%) in Angola in 1996 to that in 2000?
Your answer should be very brief. 0.82. What is the ratio of the Vaccinated children(%) of India in 1996 to that in 2000?
Your response must be concise. 0.96. What is the ratio of the Vaccinated children(%) in Low & middle income in 1996 to that in 2001?
Your response must be concise. 0.92. What is the ratio of the Vaccinated children(%) of Sub-Saharan Africa (developing only) in 1996 to that in 2001?
Provide a short and direct response. 0.83. What is the ratio of the Vaccinated children(%) of Angola in 1996 to that in 2001?
Ensure brevity in your answer.  0.77. What is the ratio of the Vaccinated children(%) in Low & middle income in 1996 to that in 2002?
Provide a succinct answer. 0.9. What is the ratio of the Vaccinated children(%) of Sub-Saharan Africa (developing only) in 1996 to that in 2002?
Provide a short and direct response. 0.78. What is the ratio of the Vaccinated children(%) of Angola in 1996 to that in 2002?
Offer a very short reply. 0.72. What is the ratio of the Vaccinated children(%) of India in 1996 to that in 2002?
Provide a succinct answer. 0.94. What is the ratio of the Vaccinated children(%) in Low & middle income in 1996 to that in 2003?
Provide a succinct answer. 0.88. What is the ratio of the Vaccinated children(%) in Sub-Saharan Africa (developing only) in 1996 to that in 2003?
Give a very brief answer. 0.76. What is the ratio of the Vaccinated children(%) of Angola in 1996 to that in 2003?
Offer a terse response. 0.69. What is the ratio of the Vaccinated children(%) of India in 1996 to that in 2003?
Give a very brief answer. 0.95. What is the ratio of the Vaccinated children(%) of Sub-Saharan Africa (developing only) in 1997 to that in 1998?
Keep it short and to the point. 0.98. What is the ratio of the Vaccinated children(%) in Angola in 1997 to that in 1998?
Offer a very short reply. 0.98. What is the ratio of the Vaccinated children(%) of Low & middle income in 1997 to that in 1999?
Provide a short and direct response. 0.98. What is the ratio of the Vaccinated children(%) in Sub-Saharan Africa (developing only) in 1997 to that in 1999?
Keep it short and to the point. 0.95. What is the ratio of the Vaccinated children(%) of Angola in 1997 to that in 1999?
Your answer should be very brief. 0.91. What is the ratio of the Vaccinated children(%) of Low & middle income in 1997 to that in 2000?
Ensure brevity in your answer.  0.95. What is the ratio of the Vaccinated children(%) in Sub-Saharan Africa (developing only) in 1997 to that in 2000?
Offer a very short reply. 0.9. What is the ratio of the Vaccinated children(%) of Low & middle income in 1997 to that in 2001?
Provide a short and direct response. 0.95. What is the ratio of the Vaccinated children(%) in Sub-Saharan Africa (developing only) in 1997 to that in 2001?
Offer a very short reply. 0.88. What is the ratio of the Vaccinated children(%) in Angola in 1997 to that in 2001?
Give a very brief answer. 0.8. What is the ratio of the Vaccinated children(%) in India in 1997 to that in 2001?
Give a very brief answer. 1.01. What is the ratio of the Vaccinated children(%) of Low & middle income in 1997 to that in 2002?
Provide a succinct answer. 0.92. What is the ratio of the Vaccinated children(%) of Sub-Saharan Africa (developing only) in 1997 to that in 2002?
Provide a short and direct response. 0.83. What is the ratio of the Vaccinated children(%) in India in 1997 to that in 2002?
Give a very brief answer. 0.97. What is the ratio of the Vaccinated children(%) of Low & middle income in 1997 to that in 2003?
Your answer should be very brief. 0.91. What is the ratio of the Vaccinated children(%) in Sub-Saharan Africa (developing only) in 1997 to that in 2003?
Give a very brief answer. 0.8. What is the ratio of the Vaccinated children(%) of Angola in 1997 to that in 2003?
Provide a short and direct response. 0.72. What is the ratio of the Vaccinated children(%) of India in 1997 to that in 2003?
Your answer should be compact. 0.98. What is the ratio of the Vaccinated children(%) in Sub-Saharan Africa (developing only) in 1998 to that in 1999?
Your response must be concise. 0.98. What is the ratio of the Vaccinated children(%) in Angola in 1998 to that in 1999?
Make the answer very short. 0.93. What is the ratio of the Vaccinated children(%) in India in 1998 to that in 1999?
Provide a short and direct response. 0.99. What is the ratio of the Vaccinated children(%) of Low & middle income in 1998 to that in 2000?
Your answer should be very brief. 0.95. What is the ratio of the Vaccinated children(%) in Sub-Saharan Africa (developing only) in 1998 to that in 2000?
Your response must be concise. 0.92. What is the ratio of the Vaccinated children(%) of Angola in 1998 to that in 2000?
Give a very brief answer. 0.87. What is the ratio of the Vaccinated children(%) in Low & middle income in 1998 to that in 2001?
Your response must be concise. 0.95. What is the ratio of the Vaccinated children(%) of Sub-Saharan Africa (developing only) in 1998 to that in 2001?
Your answer should be compact. 0.9. What is the ratio of the Vaccinated children(%) of Angola in 1998 to that in 2001?
Your answer should be very brief. 0.81. What is the ratio of the Vaccinated children(%) of Low & middle income in 1998 to that in 2002?
Provide a short and direct response. 0.92. What is the ratio of the Vaccinated children(%) in Sub-Saharan Africa (developing only) in 1998 to that in 2002?
Offer a terse response. 0.85. What is the ratio of the Vaccinated children(%) in Angola in 1998 to that in 2002?
Your answer should be very brief. 0.76. What is the ratio of the Vaccinated children(%) of India in 1998 to that in 2002?
Keep it short and to the point. 0.97. What is the ratio of the Vaccinated children(%) of Low & middle income in 1998 to that in 2003?
Provide a short and direct response. 0.91. What is the ratio of the Vaccinated children(%) in Sub-Saharan Africa (developing only) in 1998 to that in 2003?
Keep it short and to the point. 0.82. What is the ratio of the Vaccinated children(%) of Angola in 1998 to that in 2003?
Ensure brevity in your answer.  0.73. What is the ratio of the Vaccinated children(%) in India in 1998 to that in 2003?
Offer a terse response. 0.98. What is the ratio of the Vaccinated children(%) in Low & middle income in 1999 to that in 2000?
Give a very brief answer. 0.97. What is the ratio of the Vaccinated children(%) in Sub-Saharan Africa (developing only) in 1999 to that in 2000?
Offer a terse response. 0.94. What is the ratio of the Vaccinated children(%) in Angola in 1999 to that in 2000?
Ensure brevity in your answer.  0.93. What is the ratio of the Vaccinated children(%) in India in 1999 to that in 2000?
Make the answer very short. 1. What is the ratio of the Vaccinated children(%) in Low & middle income in 1999 to that in 2001?
Ensure brevity in your answer.  0.97. What is the ratio of the Vaccinated children(%) of Sub-Saharan Africa (developing only) in 1999 to that in 2001?
Provide a succinct answer. 0.92. What is the ratio of the Vaccinated children(%) of India in 1999 to that in 2001?
Keep it short and to the point. 1.02. What is the ratio of the Vaccinated children(%) in Low & middle income in 1999 to that in 2002?
Your answer should be very brief. 0.94. What is the ratio of the Vaccinated children(%) of Sub-Saharan Africa (developing only) in 1999 to that in 2002?
Offer a very short reply. 0.87. What is the ratio of the Vaccinated children(%) of Angola in 1999 to that in 2002?
Provide a short and direct response. 0.82. What is the ratio of the Vaccinated children(%) of Low & middle income in 1999 to that in 2003?
Keep it short and to the point. 0.93. What is the ratio of the Vaccinated children(%) of Sub-Saharan Africa (developing only) in 1999 to that in 2003?
Give a very brief answer. 0.84. What is the ratio of the Vaccinated children(%) in Angola in 1999 to that in 2003?
Offer a terse response. 0.79. What is the ratio of the Vaccinated children(%) in India in 1999 to that in 2003?
Give a very brief answer. 0.99. What is the ratio of the Vaccinated children(%) of Sub-Saharan Africa (developing only) in 2000 to that in 2001?
Offer a very short reply. 0.98. What is the ratio of the Vaccinated children(%) in India in 2000 to that in 2001?
Offer a terse response. 1.02. What is the ratio of the Vaccinated children(%) in Low & middle income in 2000 to that in 2002?
Provide a short and direct response. 0.97. What is the ratio of the Vaccinated children(%) of Sub-Saharan Africa (developing only) in 2000 to that in 2002?
Your response must be concise. 0.92. What is the ratio of the Vaccinated children(%) in Angola in 2000 to that in 2002?
Provide a succinct answer. 0.88. What is the ratio of the Vaccinated children(%) in Low & middle income in 2000 to that in 2003?
Make the answer very short. 0.96. What is the ratio of the Vaccinated children(%) of Sub-Saharan Africa (developing only) in 2000 to that in 2003?
Provide a succinct answer. 0.9. What is the ratio of the Vaccinated children(%) in Angola in 2000 to that in 2003?
Offer a terse response. 0.85. What is the ratio of the Vaccinated children(%) of India in 2000 to that in 2003?
Your response must be concise. 0.99. What is the ratio of the Vaccinated children(%) in Low & middle income in 2001 to that in 2002?
Your response must be concise. 0.97. What is the ratio of the Vaccinated children(%) in Sub-Saharan Africa (developing only) in 2001 to that in 2002?
Offer a terse response. 0.94. What is the ratio of the Vaccinated children(%) of India in 2001 to that in 2002?
Provide a succinct answer. 0.95. What is the ratio of the Vaccinated children(%) of Low & middle income in 2001 to that in 2003?
Your answer should be very brief. 0.96. What is the ratio of the Vaccinated children(%) of Sub-Saharan Africa (developing only) in 2001 to that in 2003?
Offer a terse response. 0.92. What is the ratio of the Vaccinated children(%) of Angola in 2001 to that in 2003?
Ensure brevity in your answer.  0.9. What is the ratio of the Vaccinated children(%) of India in 2001 to that in 2003?
Your answer should be very brief. 0.97. What is the ratio of the Vaccinated children(%) of Low & middle income in 2002 to that in 2003?
Give a very brief answer. 0.99. What is the ratio of the Vaccinated children(%) of Sub-Saharan Africa (developing only) in 2002 to that in 2003?
Ensure brevity in your answer.  0.97. What is the ratio of the Vaccinated children(%) of Angola in 2002 to that in 2003?
Ensure brevity in your answer.  0.96. What is the ratio of the Vaccinated children(%) in India in 2002 to that in 2003?
Provide a short and direct response. 1.01. What is the difference between the highest and the second highest Vaccinated children(%) in Low & middle income?
Offer a very short reply. 0.95. What is the difference between the highest and the second highest Vaccinated children(%) of Sub-Saharan Africa (developing only)?
Offer a very short reply. 1.95. What is the difference between the highest and the lowest Vaccinated children(%) of Low & middle income?
Your answer should be very brief. 8.97. What is the difference between the highest and the lowest Vaccinated children(%) in Sub-Saharan Africa (developing only)?
Give a very brief answer. 16.64. 